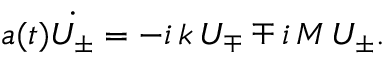Convert formula to latex. <formula><loc_0><loc_0><loc_500><loc_500>a ( t ) \dot { U _ { \pm } } = - i \, k \, U _ { \mp } \mp i \, M \, U _ { \pm } .</formula> 